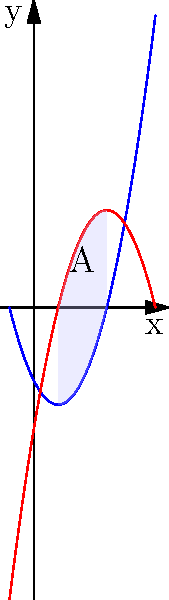As a data analyst preparing for your 10-year reunion at Ball State University, you encounter a problem involving two polynomial functions: $f(x) = x^2 - 2x - 3$ and $g(x) = -x^2 + 6x - 5$. Find the area of the region bounded by these two curves, labeled as "A" in the graph. Round your answer to two decimal places. To find the area between the two curves, we'll follow these steps:

1) Find the intersection points of the curves:
   Set $f(x) = g(x)$:
   $x^2 - 2x - 3 = -x^2 + 6x - 5$
   $2x^2 - 8x + 2 = 0$
   $x^2 - 4x + 1 = 0$
   $(x - 1)(x - 3) = 0$
   So, $x = 1$ or $x = 3$

2) The area is given by the integral of the difference between the upper and lower functions from the left intersection point to the right:

   Area = $\int_{1}^{3} [g(x) - f(x)] dx$

3) Expand the integrand:
   $g(x) - f(x) = (-x^2 + 6x - 5) - (x^2 - 2x - 3)$
                = $-2x^2 + 8x - 2$

4) Integrate:
   Area = $\int_{1}^{3} (-2x^2 + 8x - 2) dx$
        = $[-\frac{2}{3}x^3 + 4x^2 - 2x]_{1}^{3}$

5) Evaluate the integral:
   = $[-\frac{2}{3}(3)^3 + 4(3)^2 - 2(3)] - [-\frac{2}{3}(1)^3 + 4(1)^2 - 2(1)]$
   = $[-18 + 36 - 6] - [-\frac{2}{3} + 4 - 2]$
   = $12 - (\frac{4}{3})$
   = $\frac{32}{3}$

6) Convert to decimal and round to two places:
   $\frac{32}{3} \approx 10.67$
Answer: 10.67 square units 